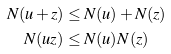<formula> <loc_0><loc_0><loc_500><loc_500>N ( u + z ) & \leq N ( u ) + N ( z ) \\ N ( u z ) & \leq N ( u ) N ( z )</formula> 